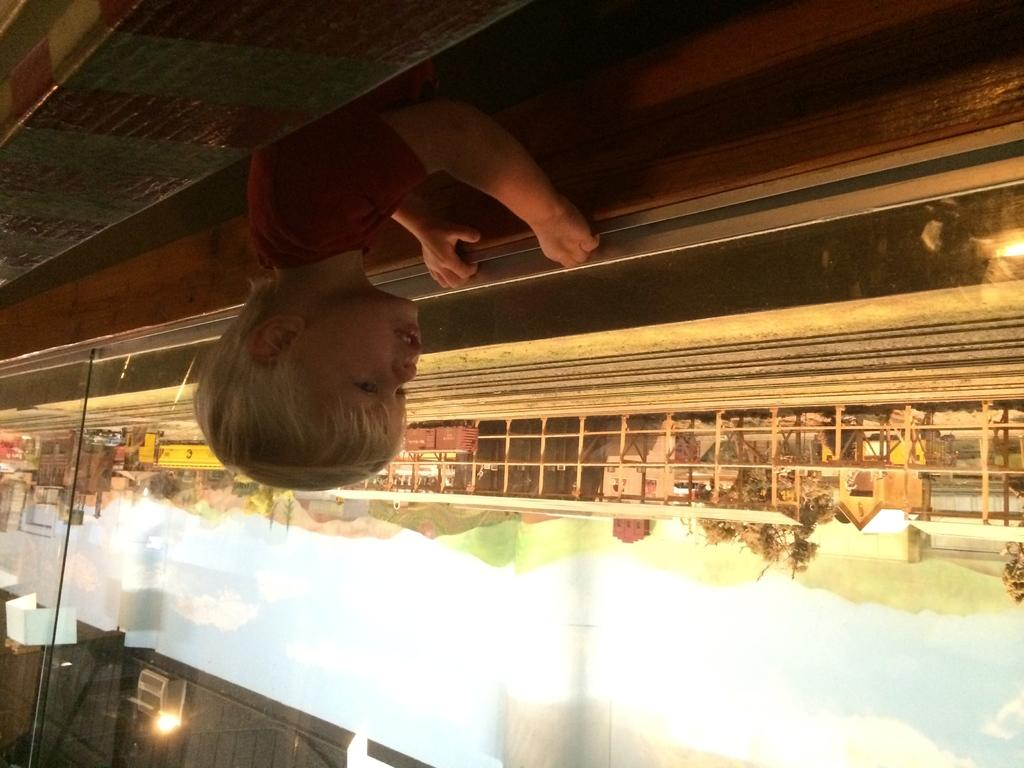What is the main subject of the image? There is a child in the image. What can be seen in the background of the image? The sky with clouds is visible in the background of the image. What type of structures are present in the image? There are buildings in the image. What other objects can be seen in the image? There is a fence and trees in the image. Are there any artificial light sources in the image? Yes, there are lights in the image. What reason does the scarecrow have for standing in the image? There is no scarecrow present in the image, so it cannot be determined what reason it might have for standing. 